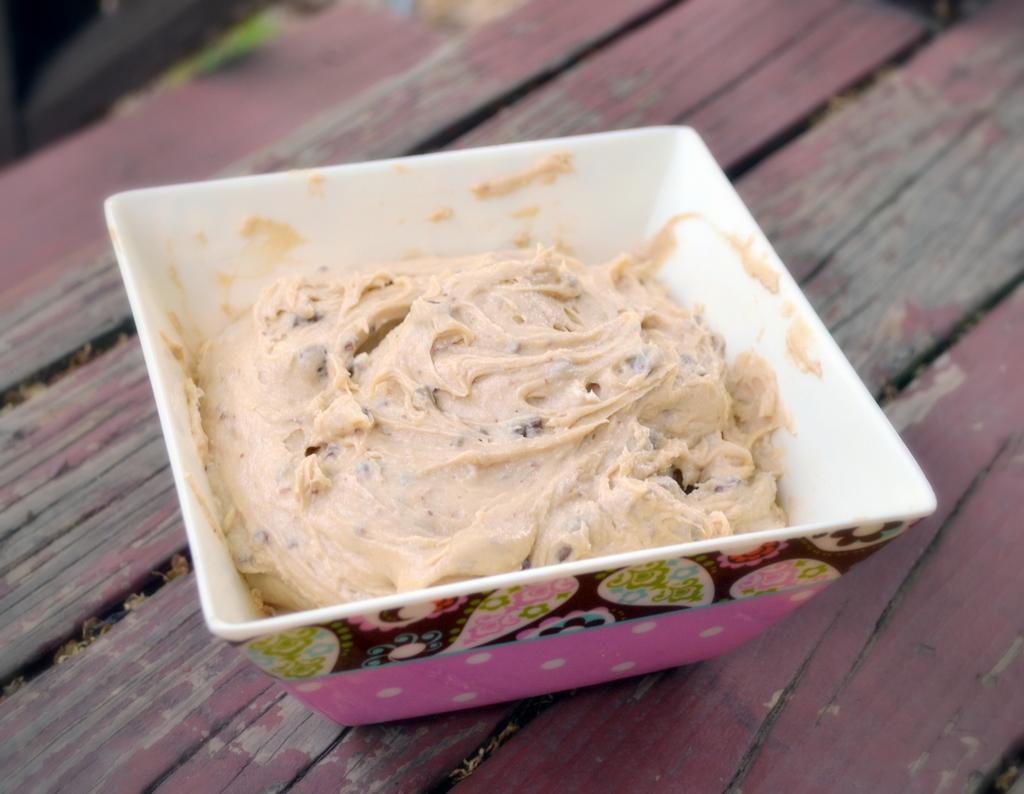Describe this image in one or two sentences. In this image we can see an ice cream in the bowl placed on the table. 